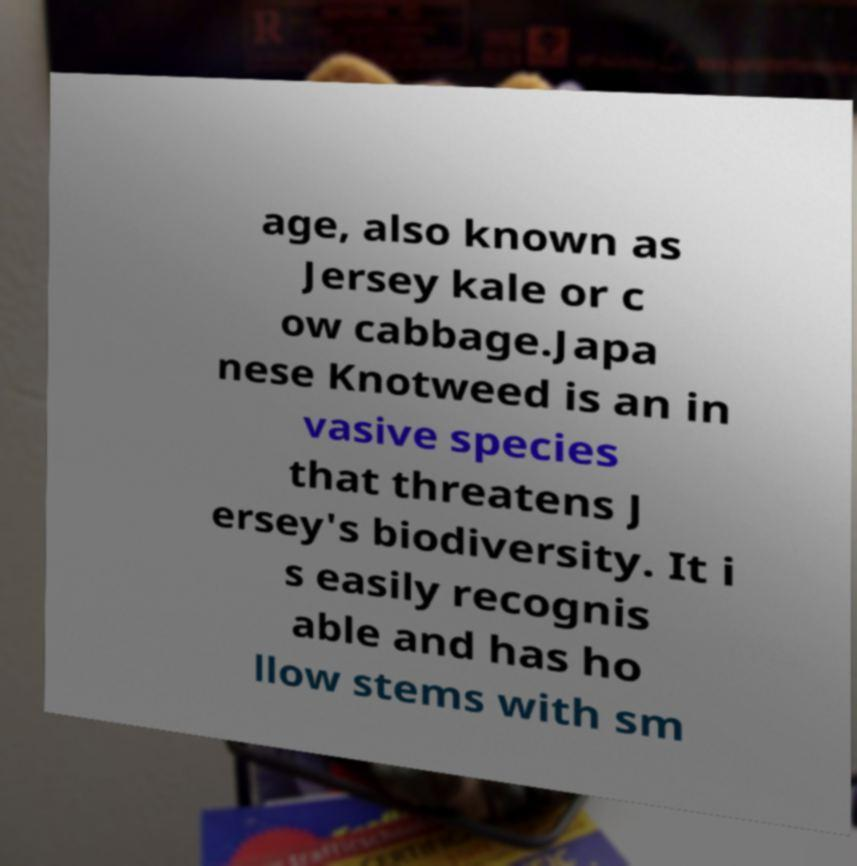Can you accurately transcribe the text from the provided image for me? age, also known as Jersey kale or c ow cabbage.Japa nese Knotweed is an in vasive species that threatens J ersey's biodiversity. It i s easily recognis able and has ho llow stems with sm 